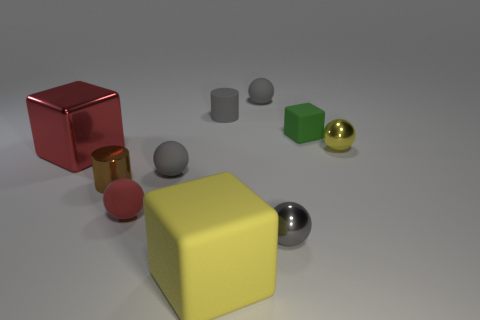There is another object that is the same color as the large metallic thing; what size is it?
Your answer should be very brief. Small. What number of things are balls that are behind the tiny yellow metal object or large green matte cylinders?
Offer a terse response. 1. How many spheres have the same material as the small cube?
Your answer should be very brief. 3. What is the shape of the object that is the same color as the shiny cube?
Your answer should be very brief. Sphere. Are there an equal number of big shiny things that are behind the tiny brown metal cylinder and big matte cubes?
Keep it short and to the point. Yes. There is a gray matte thing that is in front of the yellow ball; what is its size?
Offer a very short reply. Small. What number of large things are red metal blocks or brown cylinders?
Your response must be concise. 1. What is the color of the shiny thing that is the same shape as the tiny green matte thing?
Your answer should be compact. Red. Do the red block and the yellow matte thing have the same size?
Offer a terse response. Yes. How many things are big matte things or metal objects right of the shiny cube?
Offer a terse response. 4. 